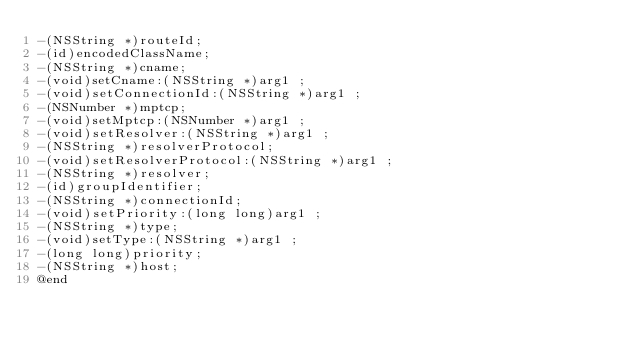Convert code to text. <code><loc_0><loc_0><loc_500><loc_500><_C_>-(NSString *)routeId;
-(id)encodedClassName;
-(NSString *)cname;
-(void)setCname:(NSString *)arg1 ;
-(void)setConnectionId:(NSString *)arg1 ;
-(NSNumber *)mptcp;
-(void)setMptcp:(NSNumber *)arg1 ;
-(void)setResolver:(NSString *)arg1 ;
-(NSString *)resolverProtocol;
-(void)setResolverProtocol:(NSString *)arg1 ;
-(NSString *)resolver;
-(id)groupIdentifier;
-(NSString *)connectionId;
-(void)setPriority:(long long)arg1 ;
-(NSString *)type;
-(void)setType:(NSString *)arg1 ;
-(long long)priority;
-(NSString *)host;
@end

</code> 